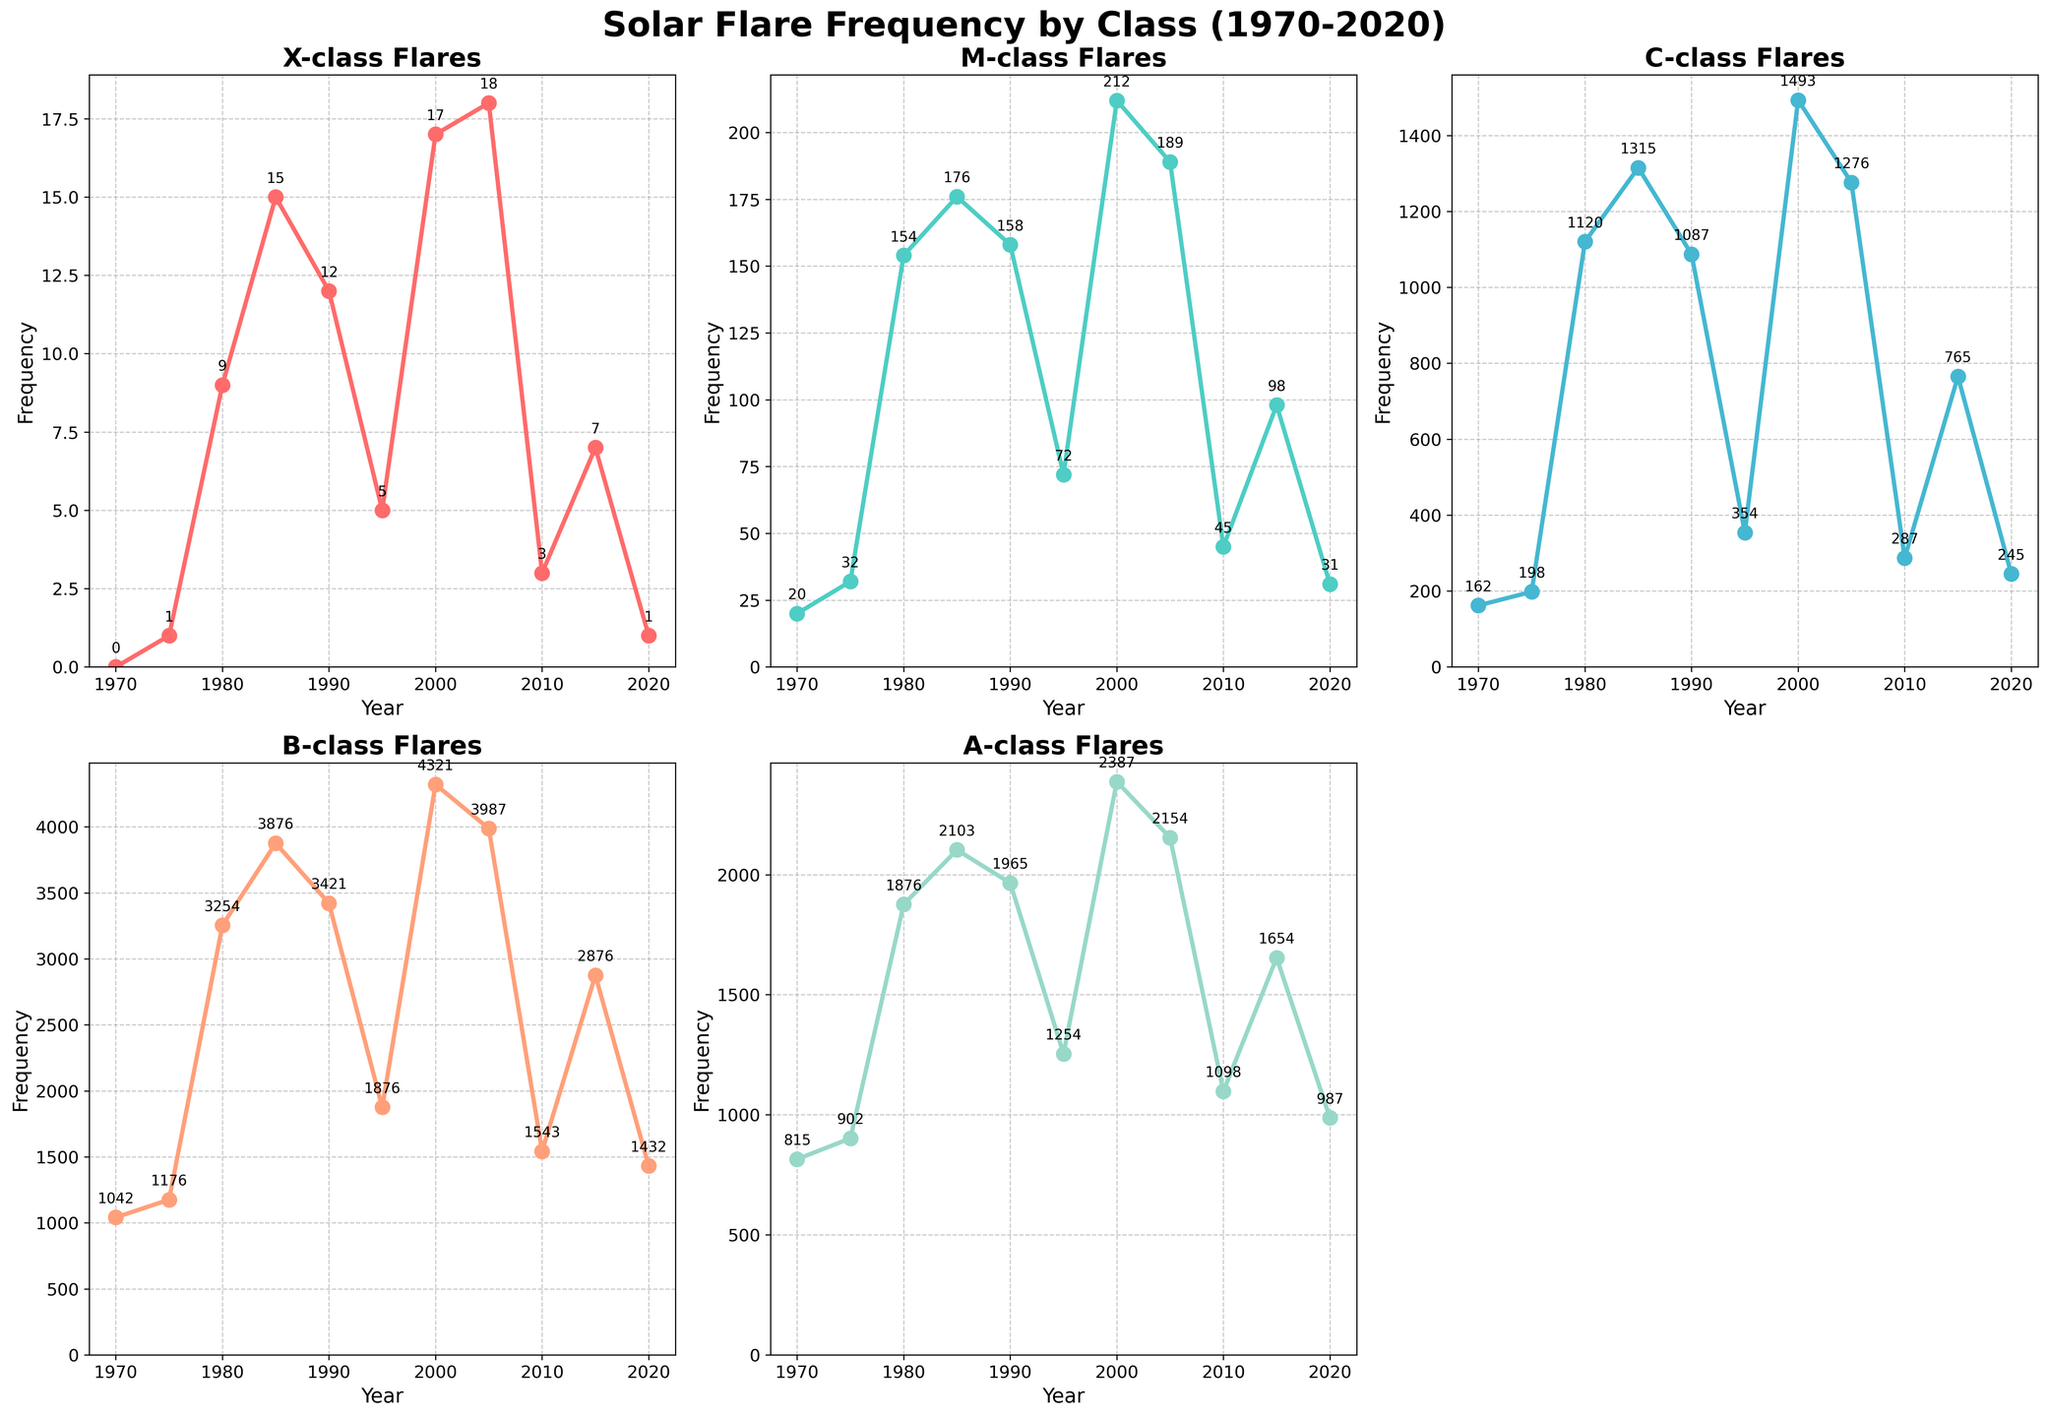what is the title of the plot? The title is displayed at the top of the figure in a bold and larger font. It reads "Solar Flare Frequency by Class (1970-2020)."
Answer: Solar Flare Frequency by Class (1970-2020) How many subplots are there in the figure? The figure contains a 2x3 grid of subplots, but one is empty, resulting in five subplots.
Answer: Five Which class of solar flares had the highest frequency in 2000? By observing the plot for the year 2000, you can see that 'A-class' flares show the highest frequency compared to all other classes.
Answer: A-class In which year did X-class flares peak, and what was the frequency? Looking at the X-class subplot, you can see that the frequency peaks in 2005 with a count of 18.
Answer: 2005 and 18 What was the B-class flare frequency in 1985? On the B-class subplot, the frequency for the year 1985 is annotated at the data point and reads 3876.
Answer: 3876 Which class had a continuous increase in frequency from 1970 to 2000? By analyzing the trends in each subplot, it appears that 'C-class' had a continuous increase in frequency from 1970 to 2000.
Answer: C-class What is the difference in frequency of M-class flares between 1980 and 2010? In the M-class subplot, the frequency in 1980 is 154 and in 2010 is 45. The difference is 154 - 45 = 109.
Answer: 109 Comparing both 'X-class' and 'B-class', in which year did both have the lowest frequency, and what was the frequency? The lowest frequency observed for X-class and B-class are in 1970: 0 for X-class and 1042 for B-class.
Answer: 1970, 0 for X-class and 1042 for B-class What trend do you observe for C-class flares from 2000 to 2020? By looking at the C-class subplot, there is a noticeable decline in frequency from 2000 (1493) to 2020 (245).
Answer: Declining Which class had a greater increase in flare frequency between 1970 and 1980, A-class or M-class? The A-class increased from 815 to 1876, a difference of 1061, while M-class increased from 20 to 154, a difference of 134. Therefore, A-class had a greater increase.
Answer: A-class 